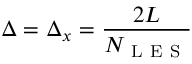<formula> <loc_0><loc_0><loc_500><loc_500>\Delta = \Delta _ { x } = \frac { 2 L } { N _ { L E S } }</formula> 